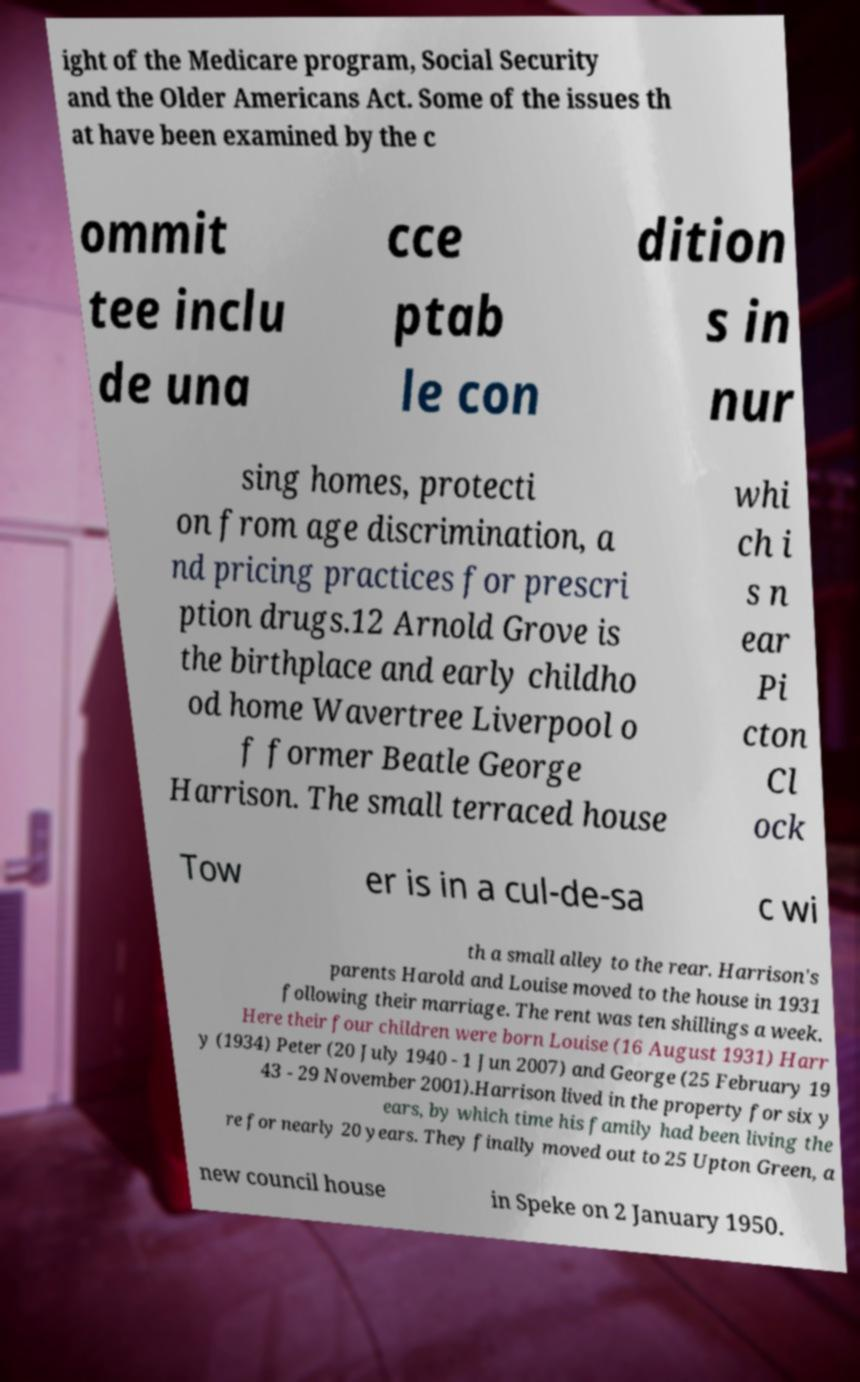I need the written content from this picture converted into text. Can you do that? ight of the Medicare program, Social Security and the Older Americans Act. Some of the issues th at have been examined by the c ommit tee inclu de una cce ptab le con dition s in nur sing homes, protecti on from age discrimination, a nd pricing practices for prescri ption drugs.12 Arnold Grove is the birthplace and early childho od home Wavertree Liverpool o f former Beatle George Harrison. The small terraced house whi ch i s n ear Pi cton Cl ock Tow er is in a cul-de-sa c wi th a small alley to the rear. Harrison's parents Harold and Louise moved to the house in 1931 following their marriage. The rent was ten shillings a week. Here their four children were born Louise (16 August 1931) Harr y (1934) Peter (20 July 1940 - 1 Jun 2007) and George (25 February 19 43 - 29 November 2001).Harrison lived in the property for six y ears, by which time his family had been living the re for nearly 20 years. They finally moved out to 25 Upton Green, a new council house in Speke on 2 January 1950. 